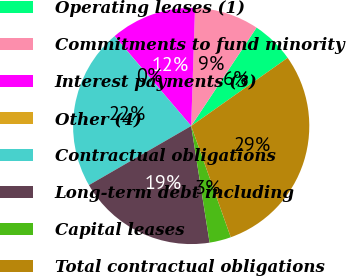Convert chart. <chart><loc_0><loc_0><loc_500><loc_500><pie_chart><fcel>Operating leases (1)<fcel>Commitments to fund minority<fcel>Interest payments (3)<fcel>Other (4)<fcel>Contractual obligations<fcel>Long-term debt including<fcel>Capital leases<fcel>Total contractual obligations<nl><fcel>5.88%<fcel>8.82%<fcel>11.75%<fcel>0.02%<fcel>22.09%<fcel>19.15%<fcel>2.95%<fcel>29.35%<nl></chart> 